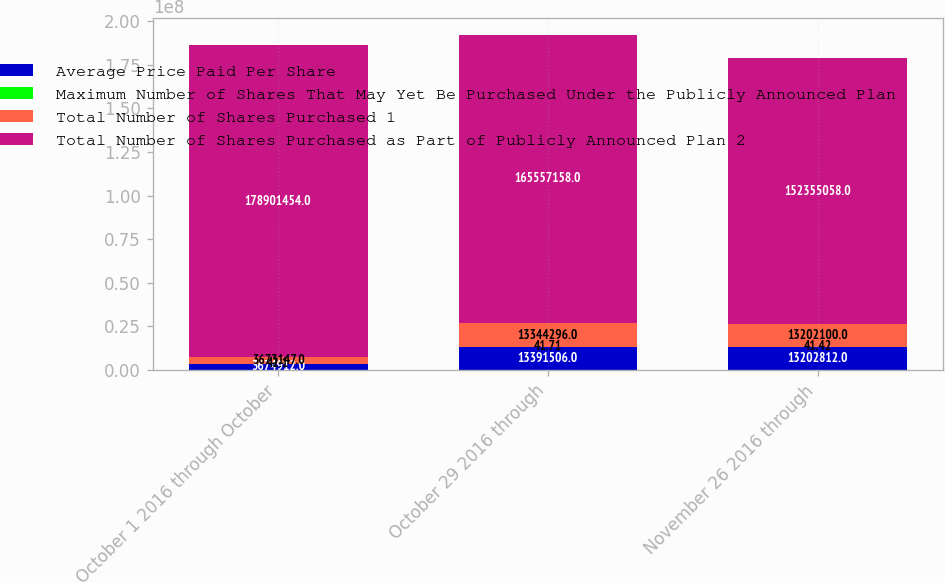Convert chart. <chart><loc_0><loc_0><loc_500><loc_500><stacked_bar_chart><ecel><fcel>October 1 2016 through October<fcel>October 29 2016 through<fcel>November 26 2016 through<nl><fcel>Average Price Paid Per Share<fcel>3.67491e+06<fcel>1.33915e+07<fcel>1.32028e+07<nl><fcel>Maximum Number of Shares That May Yet Be Purchased Under the Publicly Announced Plan<fcel>42.1<fcel>41.71<fcel>41.42<nl><fcel>Total Number of Shares Purchased 1<fcel>3.67315e+06<fcel>1.33443e+07<fcel>1.32021e+07<nl><fcel>Total Number of Shares Purchased as Part of Publicly Announced Plan 2<fcel>1.78901e+08<fcel>1.65557e+08<fcel>1.52355e+08<nl></chart> 